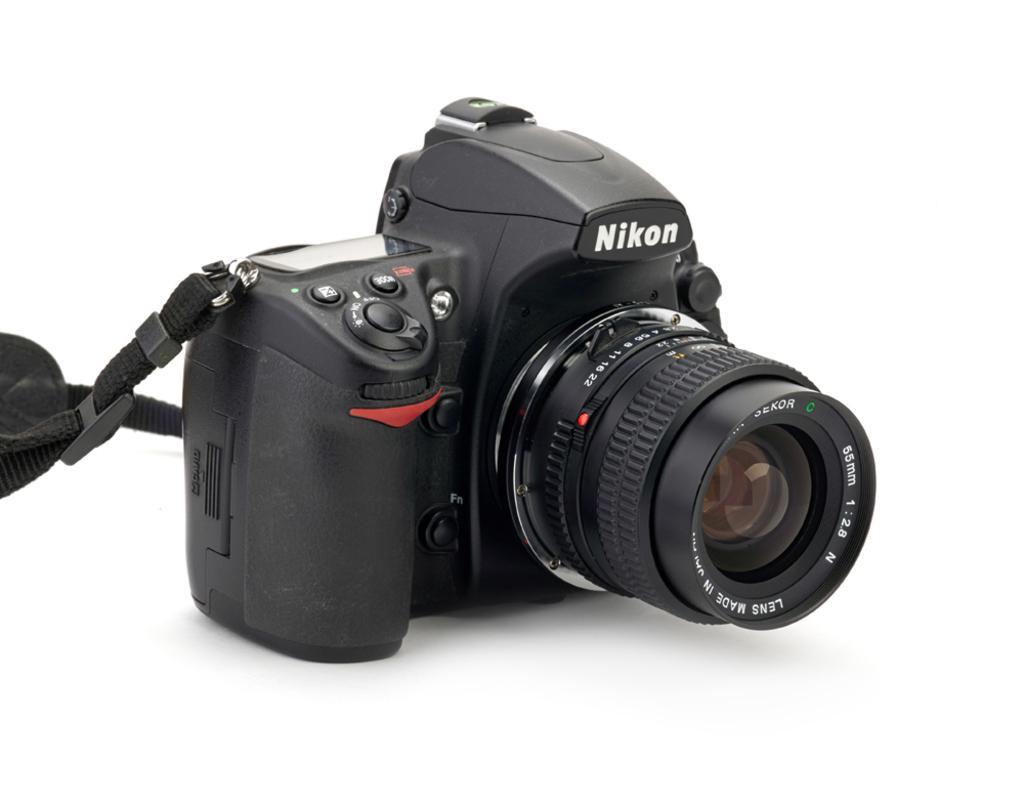Describe this image in one or two sentences. In this image I can see the black color camera on the white color surface. 